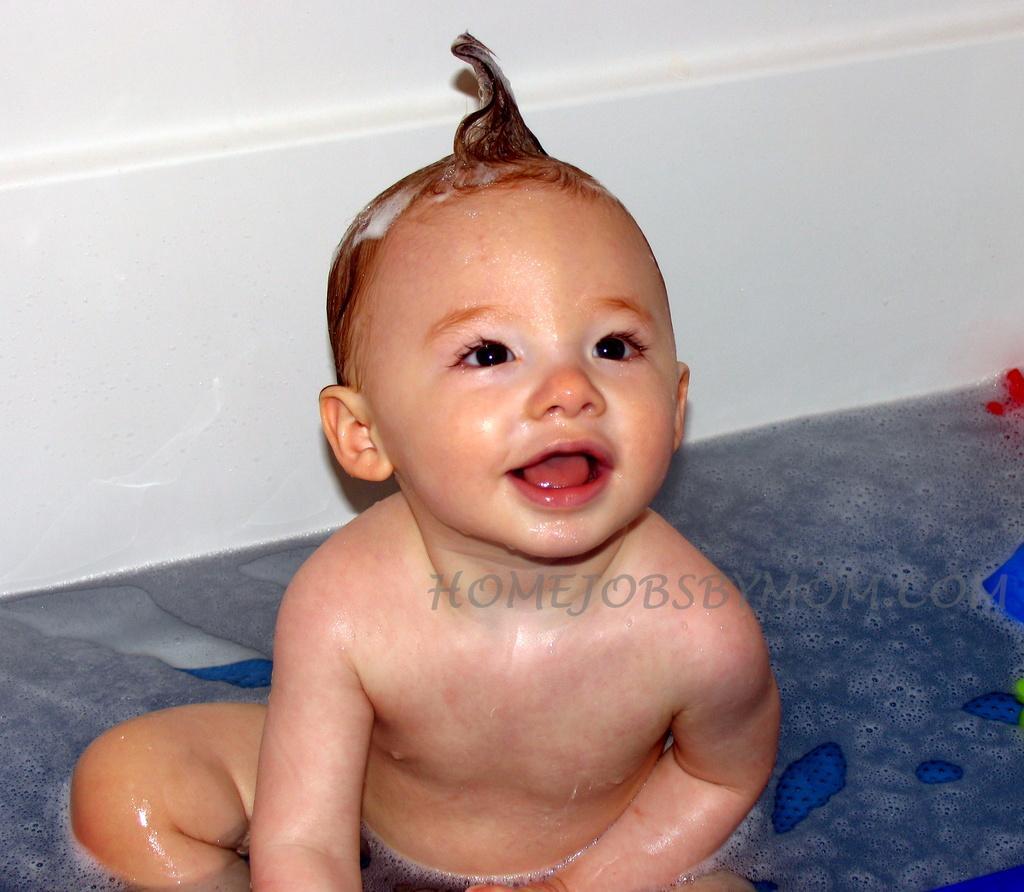In one or two sentences, can you explain what this image depicts? In this picture I can see there is a boy sitting inside a bath tub and he is looking at right and smiling, there is some water and toy in the bathtub. There is some shampoo applied to his hair. 